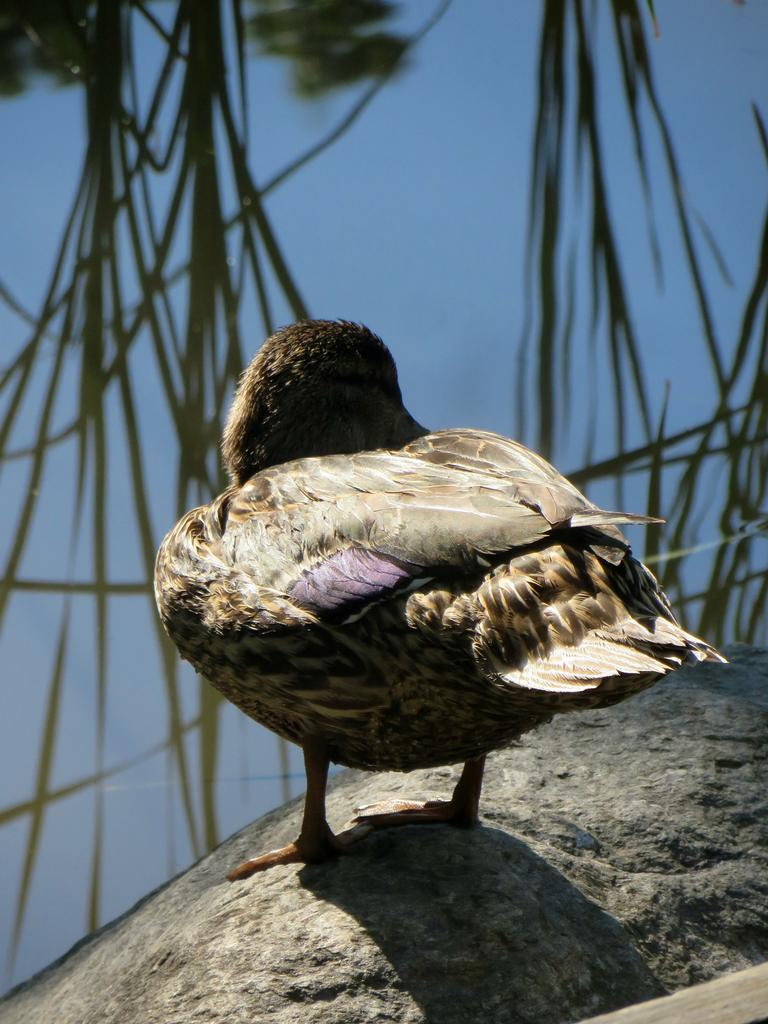What type of animal is in the image? There is a bird in the image. What is the bird standing on? The bird is standing on a stone. What can be seen in the background of the image? There is a reflection of grass on the water in the background of the image. What type of slope can be seen in the image? There is no slope present in the image. Is there any indication of a battle taking place in the image? There is no indication of a battle in the image; it features a bird standing on a stone with a grass reflection in the background. 